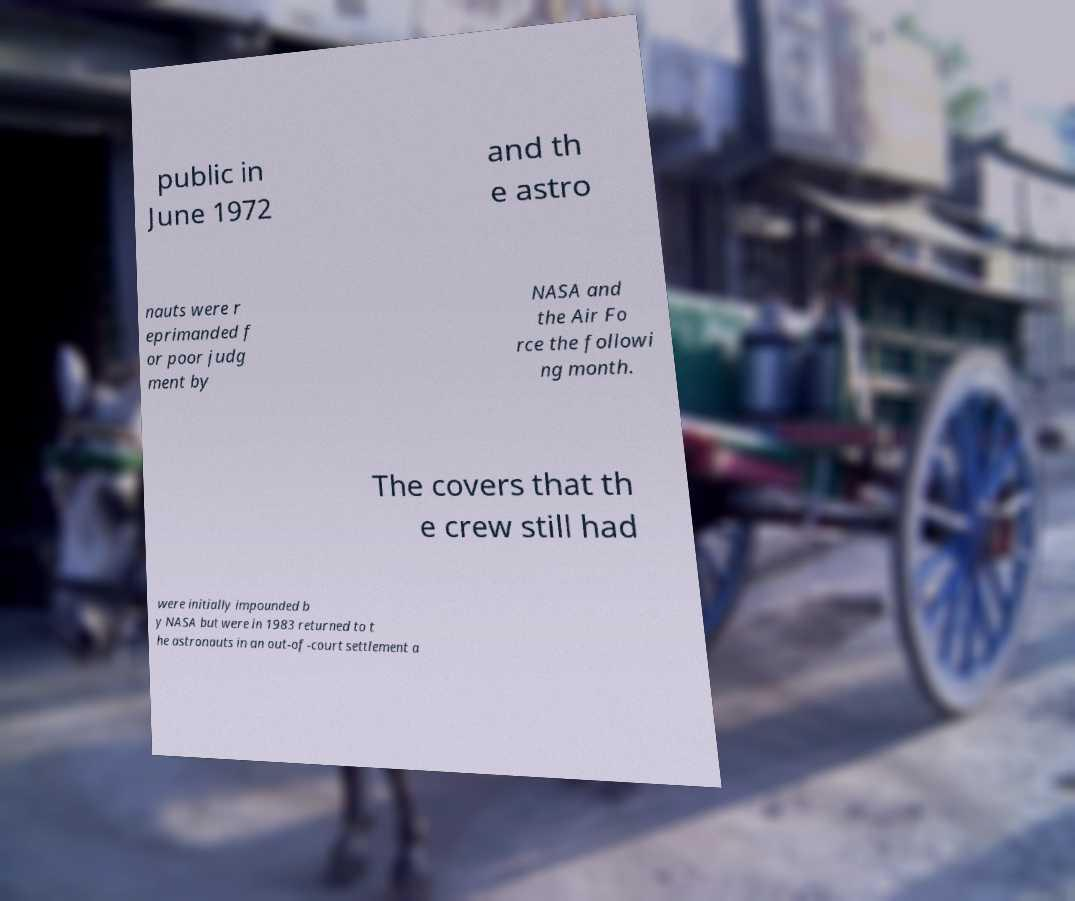Please identify and transcribe the text found in this image. public in June 1972 and th e astro nauts were r eprimanded f or poor judg ment by NASA and the Air Fo rce the followi ng month. The covers that th e crew still had were initially impounded b y NASA but were in 1983 returned to t he astronauts in an out-of-court settlement a 